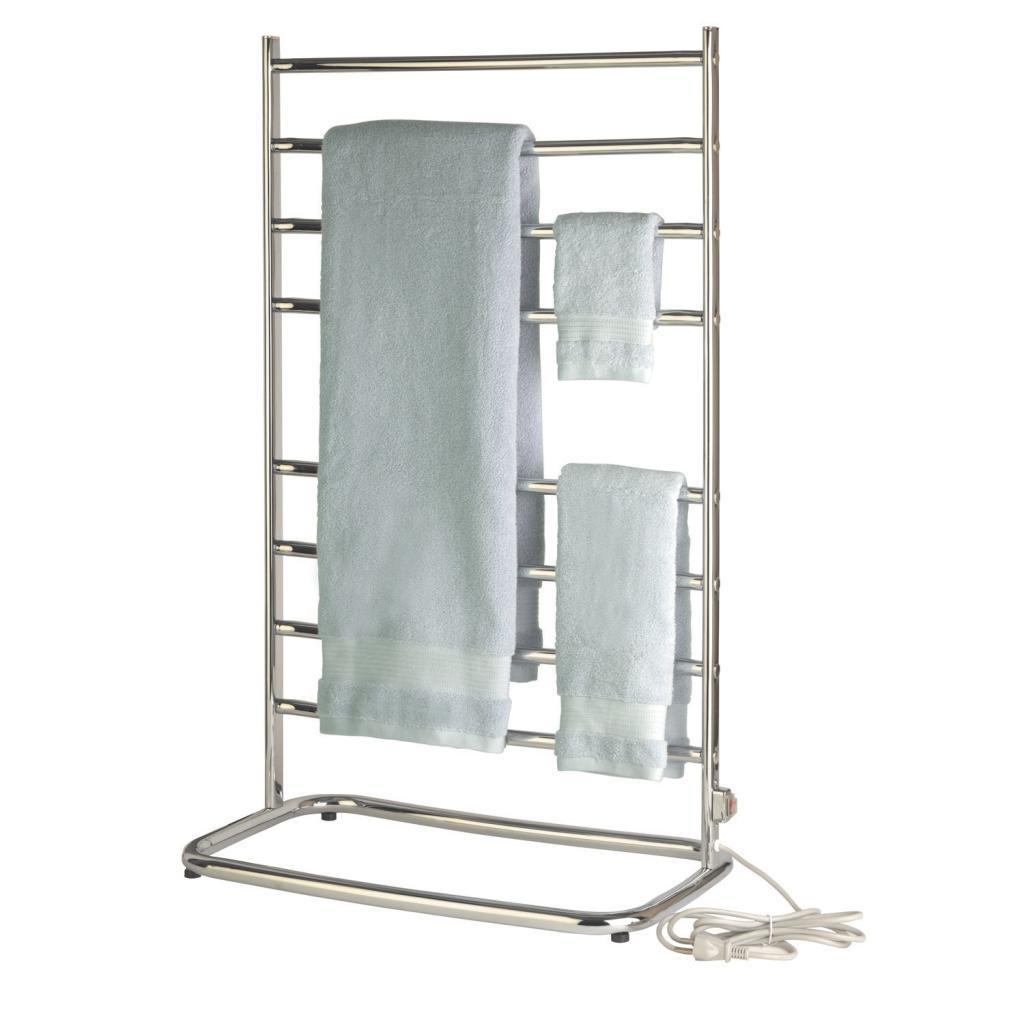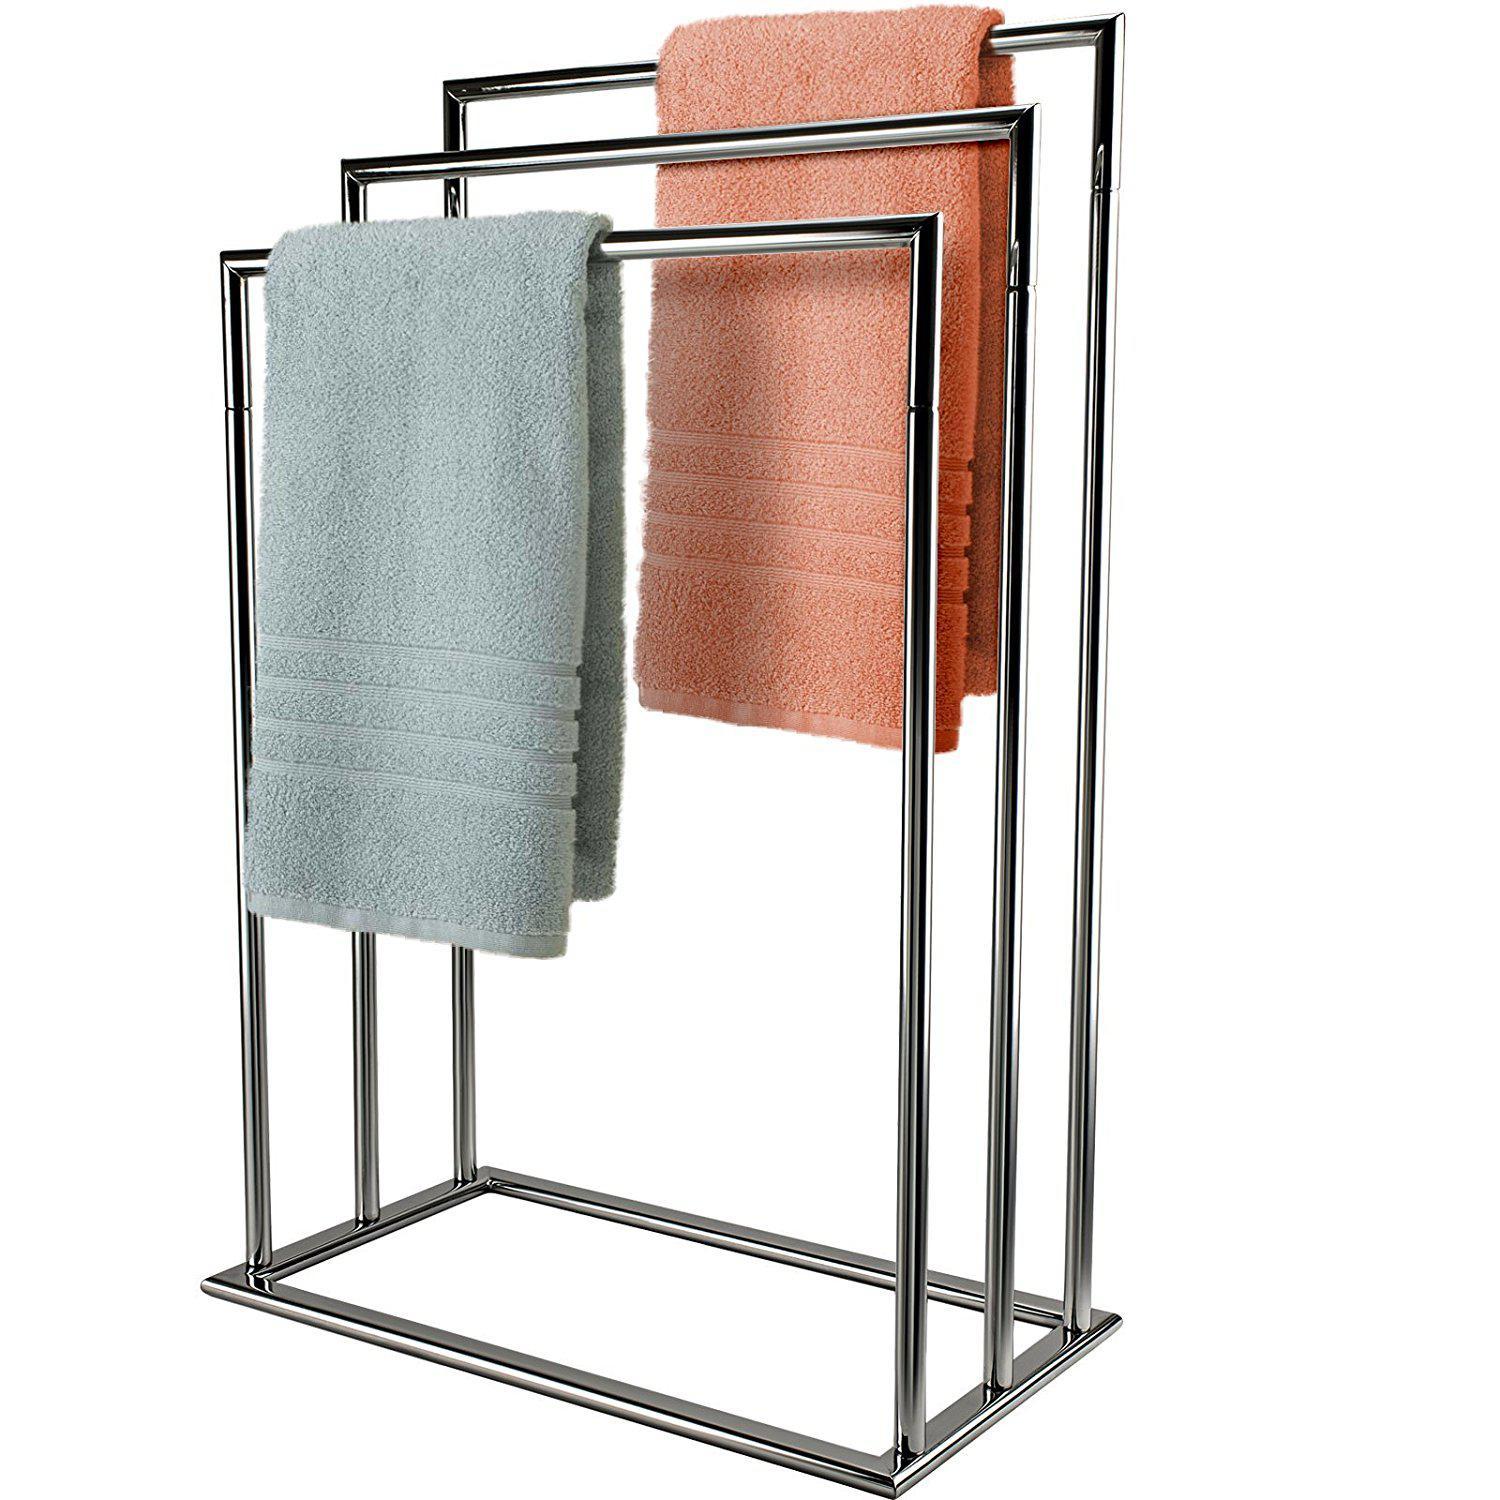The first image is the image on the left, the second image is the image on the right. Considering the images on both sides, is "One set of towels is plain, and the other has a pattern on at least a portion of it." valid? Answer yes or no. No. The first image is the image on the left, the second image is the image on the right. For the images displayed, is the sentence "dark colored towels are layers in 3's on a chrome stand" factually correct? Answer yes or no. No. 